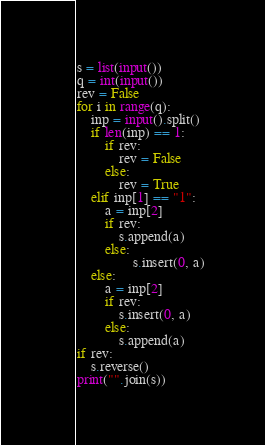<code> <loc_0><loc_0><loc_500><loc_500><_Python_>s = list(input())
q = int(input())
rev = False
for i in range(q):
    inp = input().split()
    if len(inp) == 1:
        if rev:
            rev = False
        else:
            rev = True
    elif inp[1] == "1":
        a = inp[2]
        if rev:
            s.append(a)
        else:
                s.insert(0, a)
    else:
        a = inp[2]
        if rev:
            s.insert(0, a)
        else:
            s.append(a)
if rev:
    s.reverse()
print("".join(s))</code> 